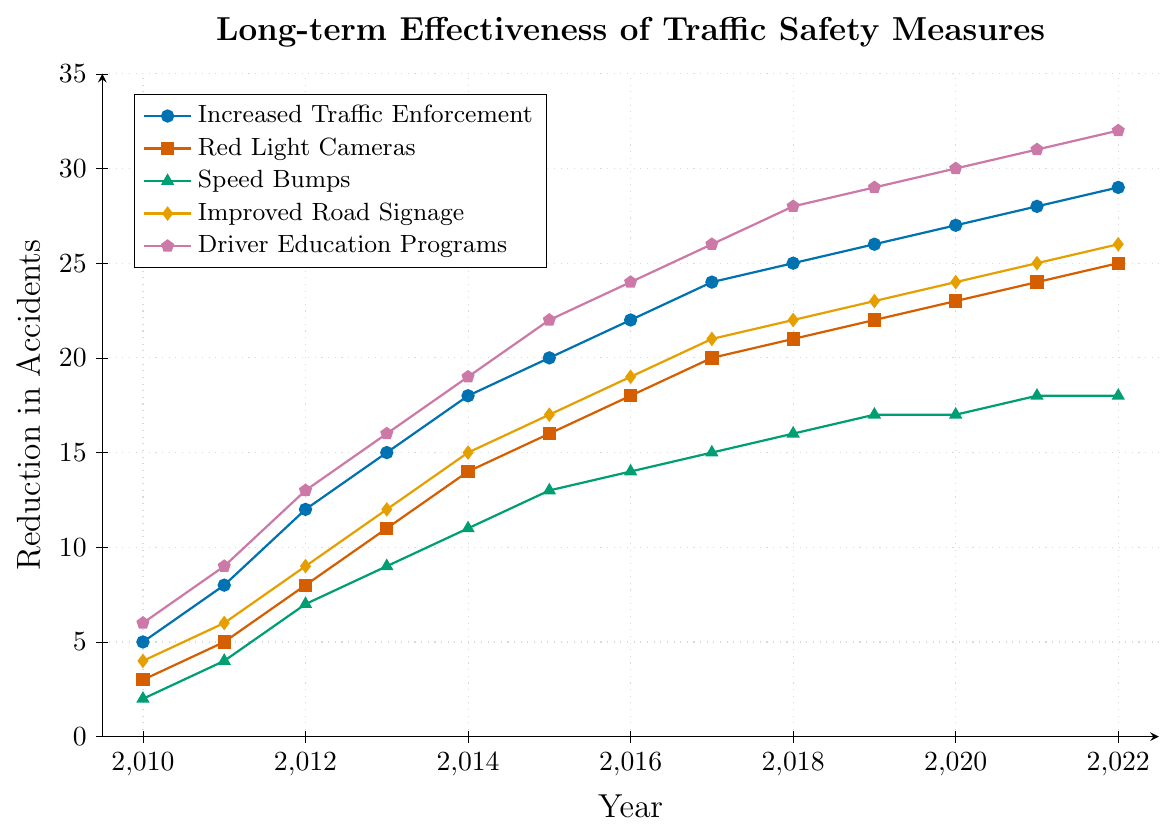What's the visual trend of the Increased Traffic Enforcement line from 2010 to 2022? The Increased Traffic Enforcement line, in blue, steadily rises from a reduction of 5 accidents in 2010 to 29 in 2022, indicating a consistent improvement in reducing accidents over time.
Answer: Steadily rising trend Which traffic safety measure had the highest reduction in accidents in 2012? Compare the y-values for all measures in 2012. The Driver Education Programs line, in purple, shows the highest reduction in accidents at 13.
Answer: Driver Education Programs By how much did the reduction in accidents from Red Light Cameras increase between 2010 and 2022? Subtract the reduction in accidents in 2010 (3) from the reduction in 2022 (25) for Red Light Cameras. \( 25 - 3 = 22 \).
Answer: 22 Which two traffic safety measures have overlapping reduction values at any year, and in which year(s)? Observe the lines for intersections. Speed Bumps and Improved Road Signage both show a reduction of 17 accidents in 2020.
Answer: Speed Bumps and Improved Road Signage in 2020 What is the average reduction in accidents for Improved Road Signage from 2010 to 2022? Sum the values from 2010 (4), 2011 (6), 2012 (9), 2013 (12), 2014 (15), 2015 (17), 2016 (19), 2017 (21), 2018 (22), 2019 (23), 2020 (24), 2021 (25), 2022 (26) and divide by the number of years (13). \( (4 + 6 + 9 + 12 + 15 + 17 + 19 + 21 + 22 + 23 + 24 + 25 + 26) / 13 = 16.85 \)
Answer: 16.85 How many traffic safety measures reached a reduction of 20 accidents by 2017? By 2017, Increased Traffic Enforcement (24), Red Light Cameras (20), and Driver Education Programs (26) all reached or exceeded a 20 reduction.
Answer: 3 In which year did Speed Bumps first achieve a reduction of 10 or more accidents? Follow the Speed Bumps line, the first year with a reduction greater than or equal to 10 is in 2013 with 9 accidents reduced, so it didn't reach 10. In 2014, it reduced 11 accidents, thus 2014.
Answer: 2014 Order these measures based on their effectiveness in reducing accidents in 2016, from highest to lowest. For 2016, compare the reduction values: Driver Education Programs (24), Increased Traffic Enforcement (22), Red Light Cameras (18), Improved Road Signage (19), Speed Bumps (14). The order is: Driver Education Programs > Increased Traffic Enforcement > Improved Road Signage > Red Light Cameras > Speed Bumps.
Answer: Driver Education Programs, Increased Traffic Enforcement, Improved Road Signage, Red Light Cameras, Speed Bumps 